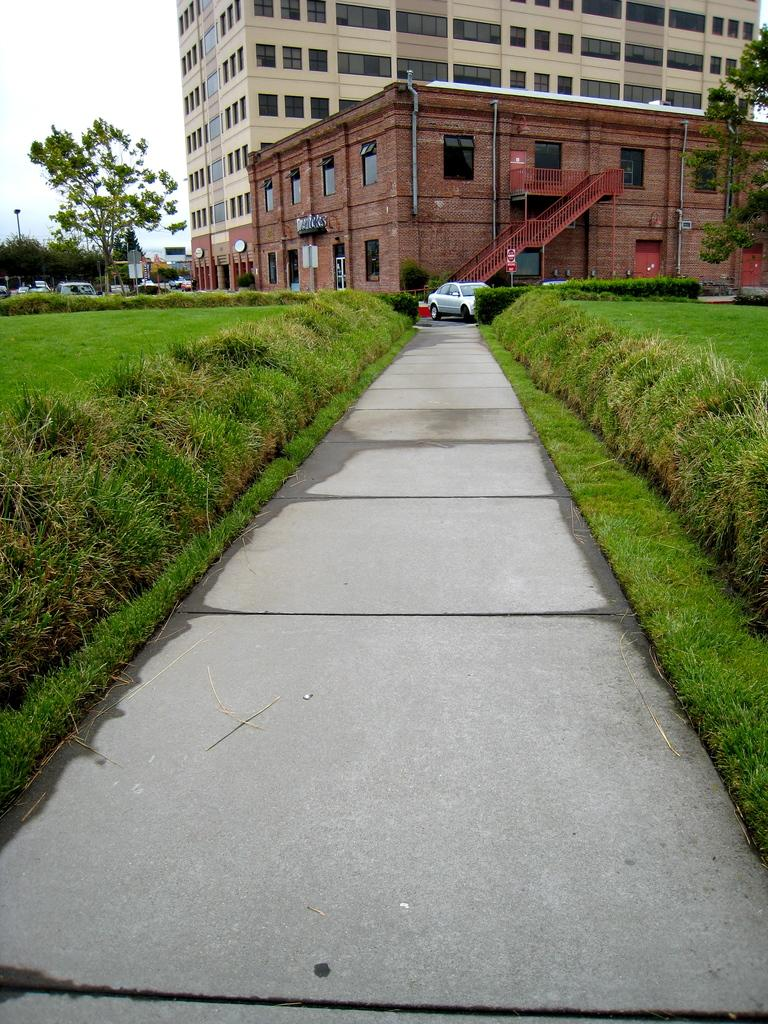What type of structures are present in the image? There are buildings in the image. What features can be observed on the buildings? The buildings have windows and stairs. What else can be seen in the image besides the buildings? There are vehicles, trees, grass, and the sky visible in the image. How does the grip of the trees compare to the grip of the buildings in the image? There is no comparison of grips in the image, as trees and buildings do not have grips. 